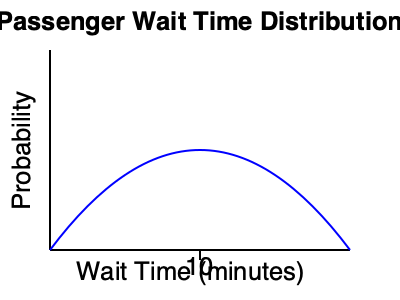As a Codeta taxi driver, you're analyzing passenger wait times. The graph shows a normal distribution of wait times with a mean of 10 minutes. If the standard deviation is 2 minutes, what percentage of passengers will wait between 8 and 12 minutes for a taxi? To solve this problem, we'll use the properties of the normal distribution and the empirical rule (68-95-99.7 rule):

1. The mean wait time is 10 minutes, and the standard deviation is 2 minutes.

2. We want to find the percentage of passengers waiting between 8 and 12 minutes.

3. Calculate how many standard deviations 8 and 12 minutes are from the mean:
   - 8 minutes: $(8 - 10) / 2 = -1$ standard deviation
   - 12 minutes: $(12 - 10) / 2 = +1$ standard deviation

4. The interval from -1 to +1 standard deviations corresponds to the middle 68% of the data in a normal distribution (according to the empirical rule).

5. Therefore, approximately 68% of passengers will wait between 8 and 12 minutes for a taxi.

This knowledge can help you set realistic expectations for passengers and optimize your taxi service.
Answer: 68% 